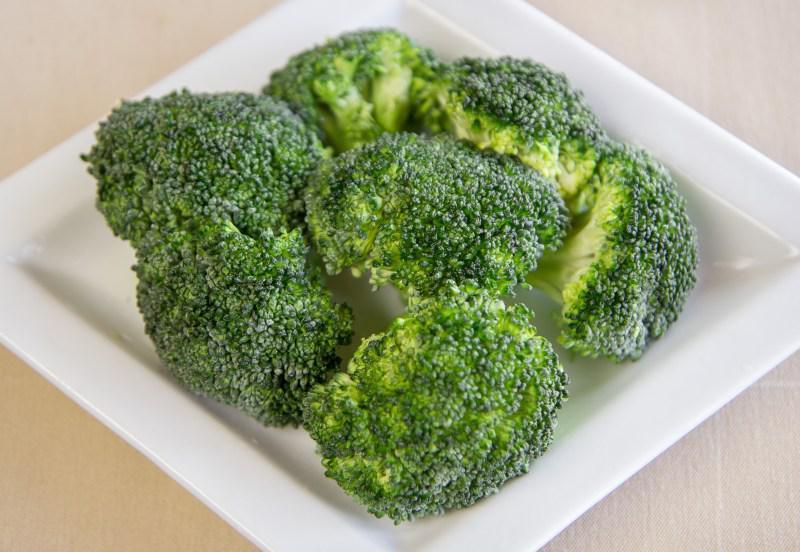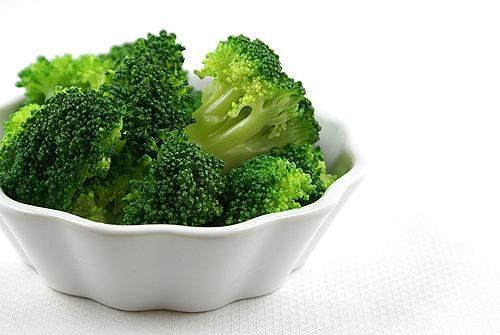The first image is the image on the left, the second image is the image on the right. Evaluate the accuracy of this statement regarding the images: "An image shows broccoli in a round container with one handle.". Is it true? Answer yes or no. No. 